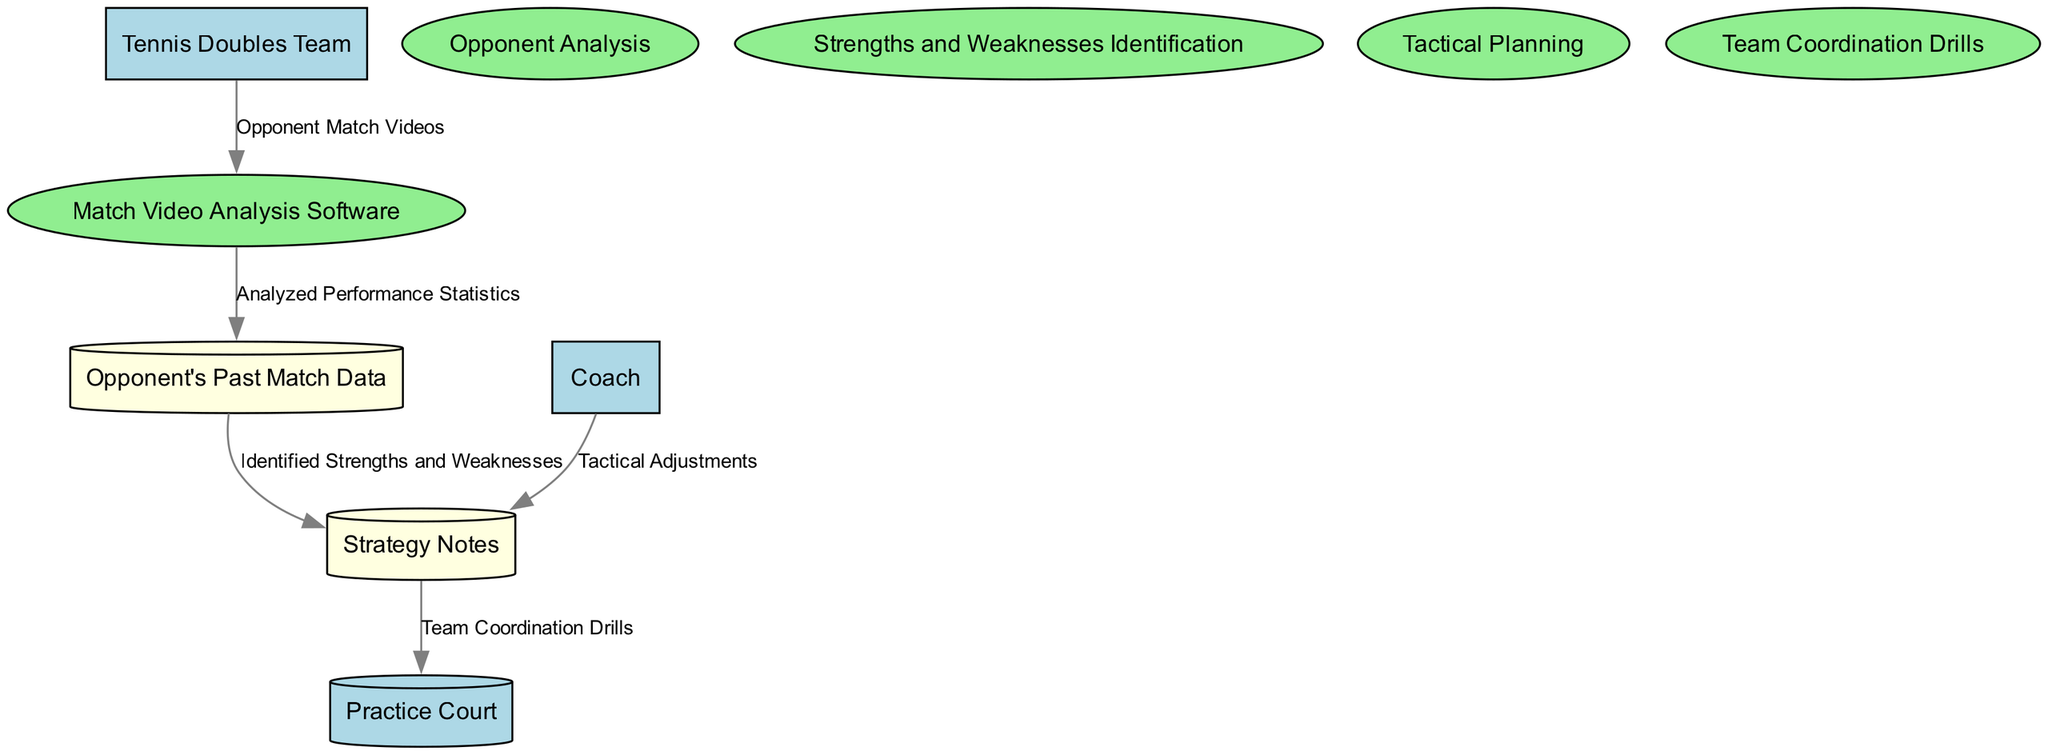What is the source of the data flow entering the Match Video Analysis Software? The Match Video Analysis Software receives data from the Tennis Doubles Team, specifically in the form of Opponent Match Videos.
Answer: Tennis Doubles Team What type of data store is used for storing Opponent's Past Match Data? The diagram shows Opponent's Past Match Data as a Data Store, which is represented by a cylinder shape filled with light yellow color.
Answer: Data Store How many processes are there in the diagram? The diagram lists four distinct processes, which are Opponent Analysis, Strengths and Weaknesses Identification, Tactical Planning, and Team Coordination Drills.
Answer: Four Which process outputs the Identified Strengths and Weaknesses? The process that outputs Identified Strengths and Weaknesses is Strengths and Weaknesses Identification, which takes Analyzed Performance Statistics as input.
Answer: Strengths and Weaknesses Identification Where does the Strategy Notes flow to after being generated? After being created in the Tactical Planning process, the Strategy Notes flow to the Practice Court, which indicates that team coordination drills will be implemented based on the notes.
Answer: Practice Court What kind of external entity is the Coach classified as in the diagram? The Coach is classified as an External Entity in the diagram, which means it interacts with the internal processes without being part of the processes themselves.
Answer: External Entity Which data flow involves Tactical Adjustments? The data flow involving Tactical Adjustments occurs between the Coach and the Strategy Notes, indicating that the Coach provides tactical adjustments to be noted in the strategy.
Answer: Coach to Strategy Notes What is the initial input needed for the Opponent Analysis process? The initial input for the Opponent Analysis process is the Opponent Match Videos, which is essential for analyzing the performance of opponents.
Answer: Opponent Match Videos Which output from the Match Video Analysis Software is necessary for the next process? The output necessary for the next process is Analyzed Performance Statistics, which is crucial for the Strengths and Weaknesses Identification process to proceed.
Answer: Analyzed Performance Statistics 